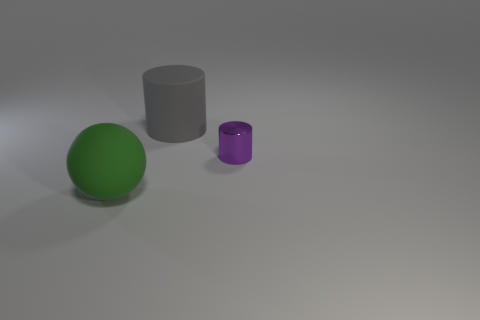What number of other metal things are the same shape as the gray thing?
Give a very brief answer. 1. There is a object that is right of the big cylinder; is it the same color as the big rubber cylinder right of the green matte object?
Make the answer very short. No. There is a green object that is the same size as the matte cylinder; what material is it?
Give a very brief answer. Rubber. Are there any balls of the same size as the purple metallic object?
Offer a terse response. No. Is the number of things that are to the right of the small metal thing less than the number of green spheres?
Provide a short and direct response. Yes. Is the number of small cylinders in front of the sphere less than the number of big gray matte objects in front of the rubber cylinder?
Give a very brief answer. No. How many cubes are either small purple things or big rubber things?
Your answer should be very brief. 0. Is the big object that is behind the purple thing made of the same material as the large object in front of the tiny purple metal cylinder?
Ensure brevity in your answer.  Yes. The other rubber thing that is the same size as the gray matte object is what shape?
Your response must be concise. Sphere. What number of other objects are the same color as the matte sphere?
Give a very brief answer. 0. 